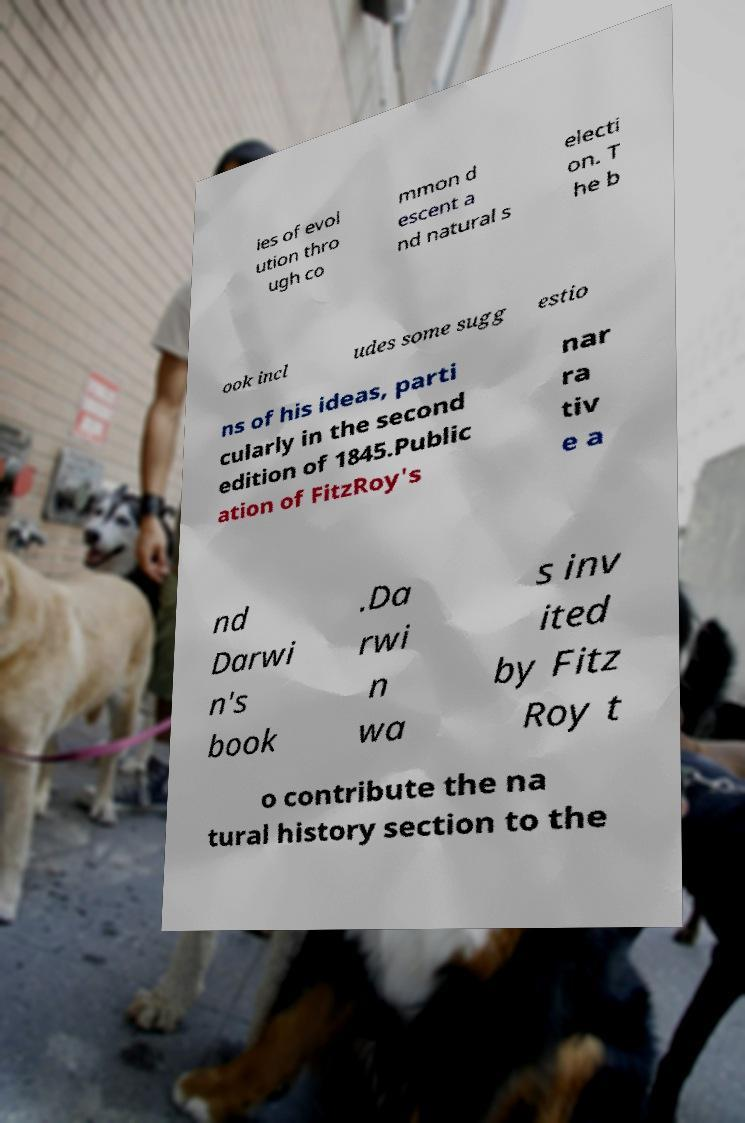Can you read and provide the text displayed in the image?This photo seems to have some interesting text. Can you extract and type it out for me? ies of evol ution thro ugh co mmon d escent a nd natural s electi on. T he b ook incl udes some sugg estio ns of his ideas, parti cularly in the second edition of 1845.Public ation of FitzRoy's nar ra tiv e a nd Darwi n's book .Da rwi n wa s inv ited by Fitz Roy t o contribute the na tural history section to the 